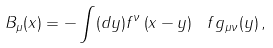<formula> <loc_0><loc_0><loc_500><loc_500>B _ { \mu } ( x ) = - \int ( d y ) f ^ { \nu } \left ( x - y \right ) \ f g _ { \mu \nu } ( y ) \, ,</formula> 